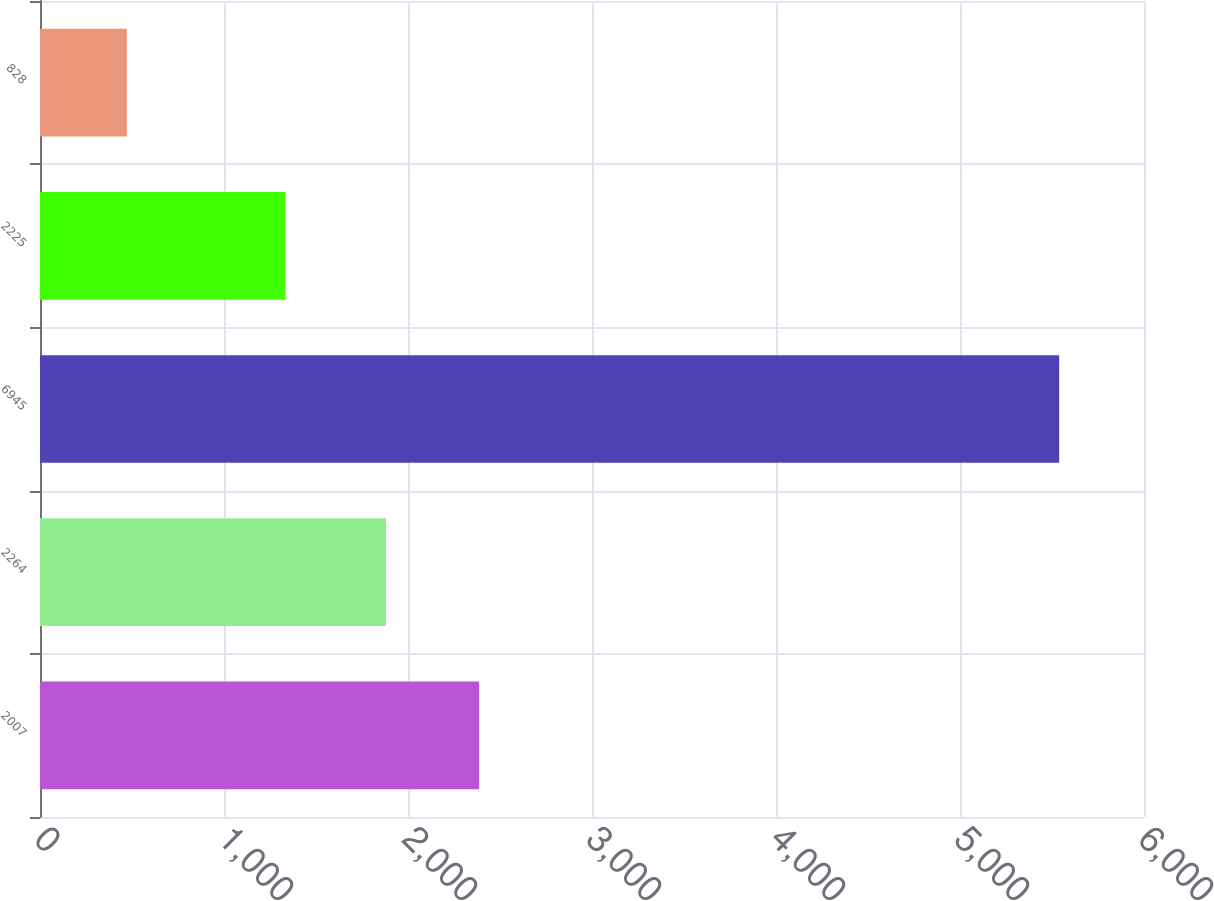Convert chart to OTSL. <chart><loc_0><loc_0><loc_500><loc_500><bar_chart><fcel>2007<fcel>2264<fcel>6945<fcel>2225<fcel>828<nl><fcel>2386.7<fcel>1880<fcel>5539<fcel>1335<fcel>472<nl></chart> 